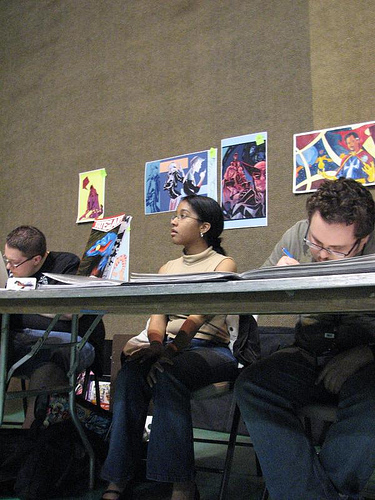<image>
Can you confirm if the drawing is behind the person? Yes. From this viewpoint, the drawing is positioned behind the person, with the person partially or fully occluding the drawing. 